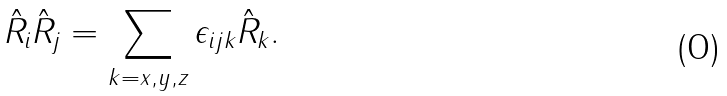Convert formula to latex. <formula><loc_0><loc_0><loc_500><loc_500>\hat { R } _ { i } \hat { R } _ { j } = \sum _ { k = x , y , z } \epsilon _ { i j k } \hat { R } _ { k } .</formula> 